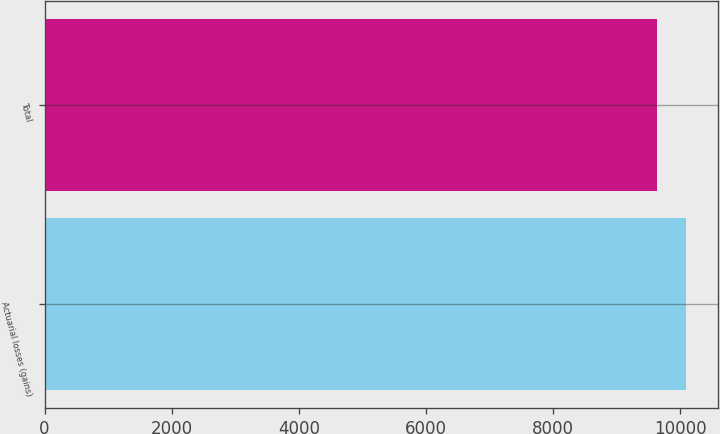Convert chart to OTSL. <chart><loc_0><loc_0><loc_500><loc_500><bar_chart><fcel>Actuarial losses (gains)<fcel>Total<nl><fcel>10092<fcel>9635<nl></chart> 